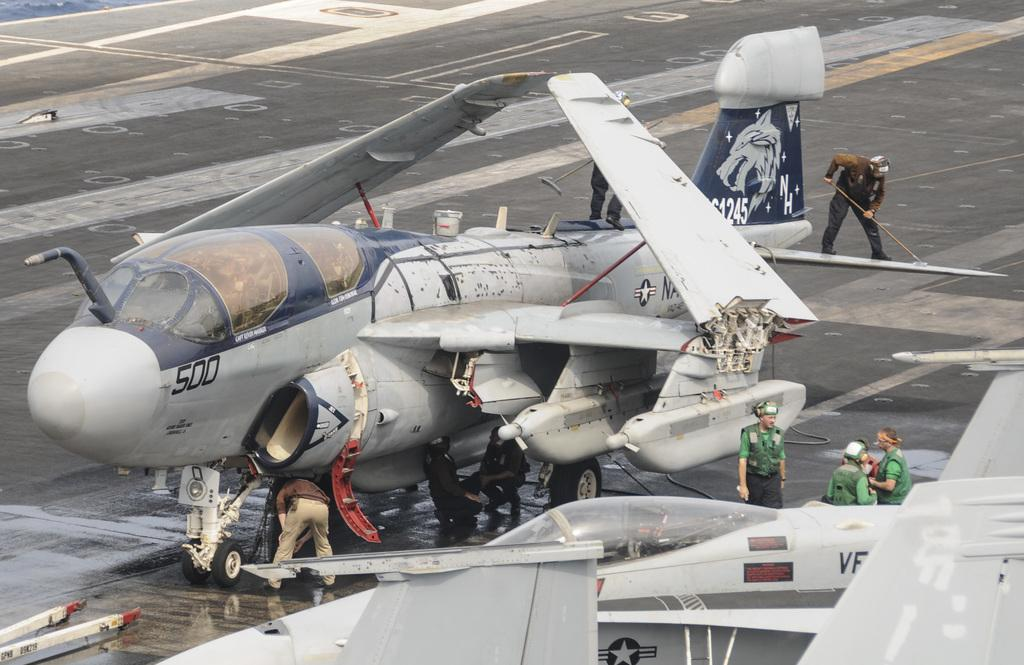<image>
Render a clear and concise summary of the photo. Gray and blue airplane parked with the number 500 on the front. 